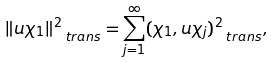Convert formula to latex. <formula><loc_0><loc_0><loc_500><loc_500>\| u \chi _ { 1 } \| _ { \, \ t r a n s } ^ { 2 } = \sum _ { j = 1 } ^ { \infty } ( \chi _ { 1 } , u \chi _ { j } ) _ { \, \ t r a n s } ^ { 2 } ,</formula> 